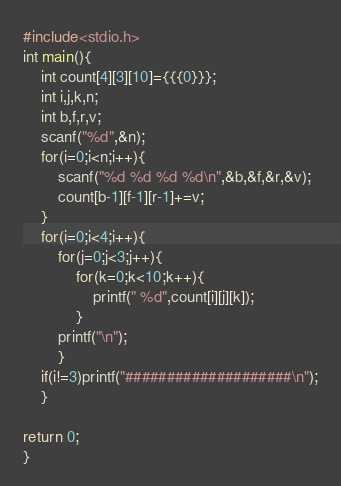<code> <loc_0><loc_0><loc_500><loc_500><_C_>
#include<stdio.h>
int main(){
    int count[4][3][10]={{{0}}};
    int i,j,k,n;
    int b,f,r,v;
    scanf("%d",&n);
    for(i=0;i<n;i++){
        scanf("%d %d %d %d\n",&b,&f,&r,&v);
        count[b-1][f-1][r-1]+=v;
    }
    for(i=0;i<4;i++){
        for(j=0;j<3;j++){
            for(k=0;k<10;k++){
                printf(" %d",count[i][j][k]);
            }
        printf("\n");
        }
    if(i!=3)printf("####################\n");
    }

return 0;
}


</code> 